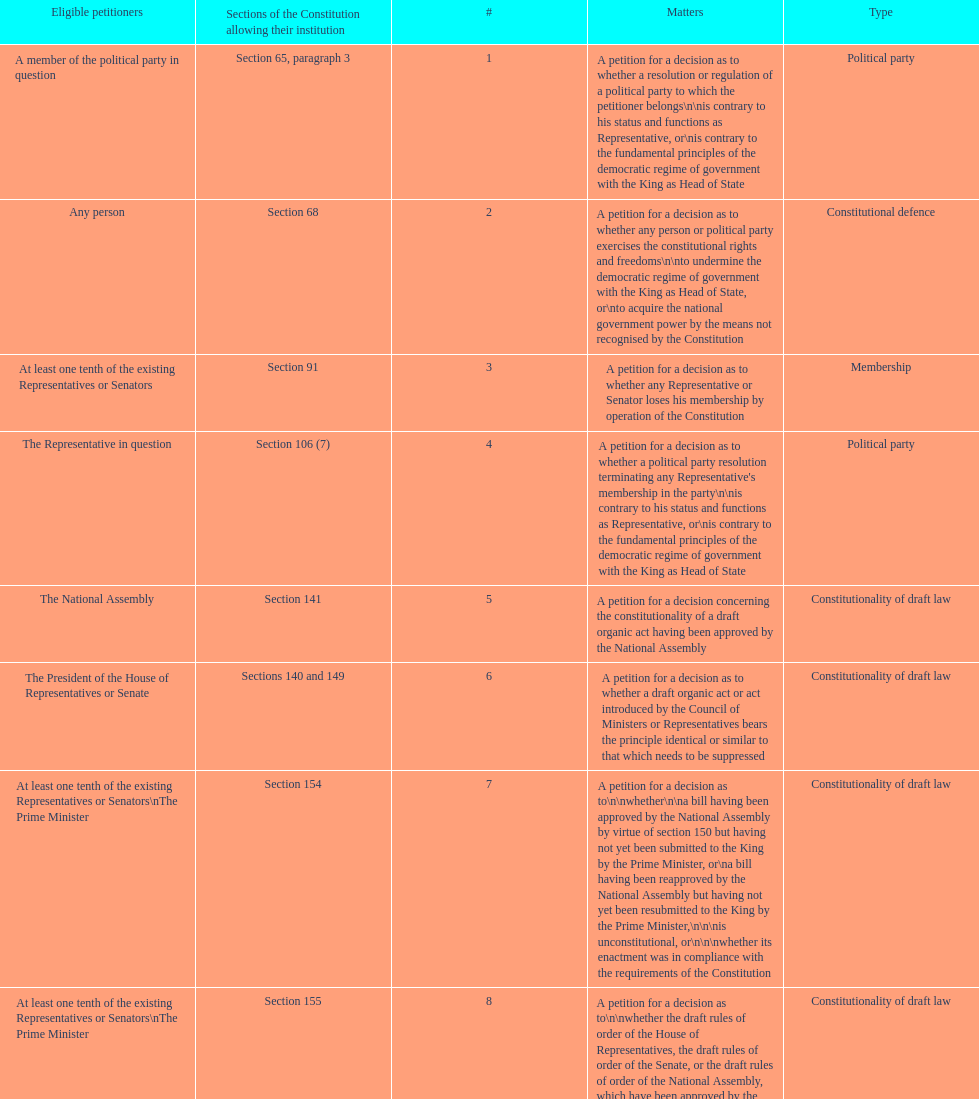Any person can petition matters 2 and 17. true or false? True. 